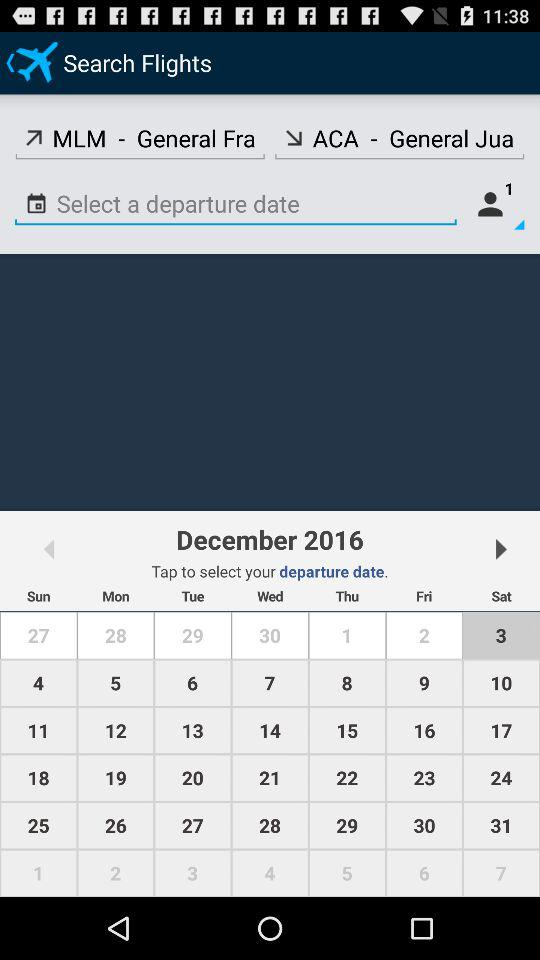Which month is selected? The selected month is December. 